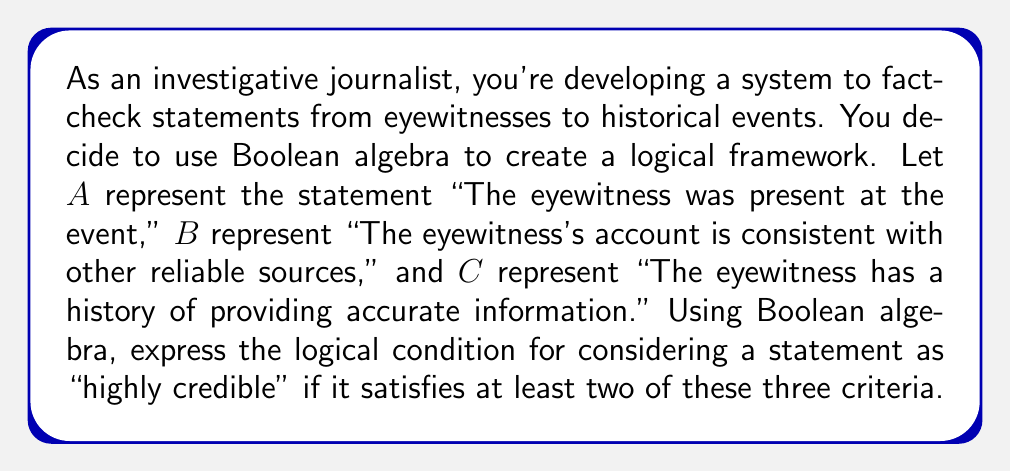Solve this math problem. To solve this problem, we need to use Boolean algebra to create a logical expression that represents the condition of "at least two out of three criteria being true."

1) First, let's consider the possible combinations that satisfy our condition:
   - A and B are true (C can be either true or false)
   - A and C are true (B can be either true or false)
   - B and C are true (A can be either true or false)

2) We can express each of these combinations using Boolean AND (∧) operation:
   $$(A \land B) \lor (A \land C) \lor (B \land C)$$

3) This expression already satisfies our condition, but we can simplify it further using Boolean algebra laws:

   $$(A \land B) \lor (A \land C) \lor (B \land C)$$
   $$= A \land (B \lor C) \lor (B \land C)$$ (using distributive law)
   $$= (A \land B) \lor (A \land C) \lor (B \land C)$$ (using distributive law again)

4) This final expression represents our logical framework for considering a statement as "highly credible."

5) In terms of implementation, this could be translated into a simple scoring system:
   - Assign 1 if a condition is true, 0 if false
   - Calculate the sum of A, B, and C
   - If the sum is greater than or equal to 2, the statement is considered "highly credible"

This approach provides a systematic way to evaluate the credibility of eyewitness statements based on multiple criteria.
Answer: $$(A \land B) \lor (A \land C) \lor (B \land C)$$ 